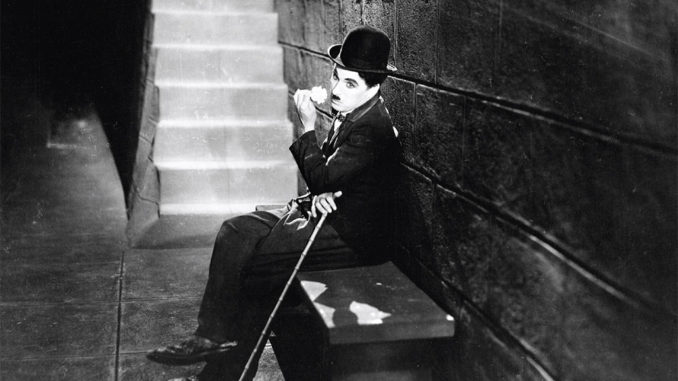What might be going through the mind of Chaplin's character in this scene? In this pensive pose, Chaplin’s Tramp might be contemplating his next move in a world that often treats him unkindly. The stark stone backdrop could signify the harsh realities of the time, reflecting societal challenges like poverty and inequality that were recurrent themes in Chaplin's films. 